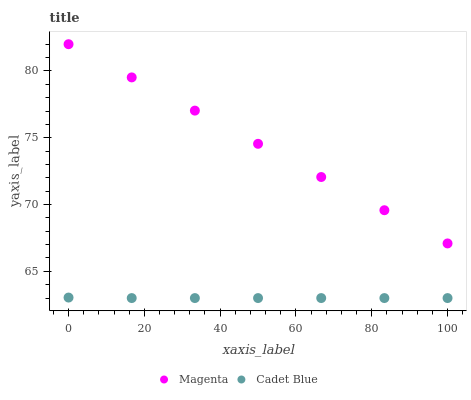Does Cadet Blue have the minimum area under the curve?
Answer yes or no. Yes. Does Magenta have the maximum area under the curve?
Answer yes or no. Yes. Does Cadet Blue have the maximum area under the curve?
Answer yes or no. No. Is Magenta the smoothest?
Answer yes or no. Yes. Is Cadet Blue the roughest?
Answer yes or no. Yes. Is Cadet Blue the smoothest?
Answer yes or no. No. Does Cadet Blue have the lowest value?
Answer yes or no. Yes. Does Magenta have the highest value?
Answer yes or no. Yes. Does Cadet Blue have the highest value?
Answer yes or no. No. Is Cadet Blue less than Magenta?
Answer yes or no. Yes. Is Magenta greater than Cadet Blue?
Answer yes or no. Yes. Does Cadet Blue intersect Magenta?
Answer yes or no. No. 